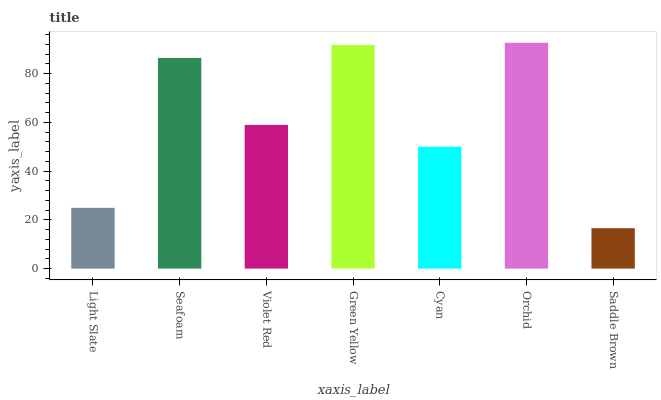Is Saddle Brown the minimum?
Answer yes or no. Yes. Is Orchid the maximum?
Answer yes or no. Yes. Is Seafoam the minimum?
Answer yes or no. No. Is Seafoam the maximum?
Answer yes or no. No. Is Seafoam greater than Light Slate?
Answer yes or no. Yes. Is Light Slate less than Seafoam?
Answer yes or no. Yes. Is Light Slate greater than Seafoam?
Answer yes or no. No. Is Seafoam less than Light Slate?
Answer yes or no. No. Is Violet Red the high median?
Answer yes or no. Yes. Is Violet Red the low median?
Answer yes or no. Yes. Is Seafoam the high median?
Answer yes or no. No. Is Saddle Brown the low median?
Answer yes or no. No. 